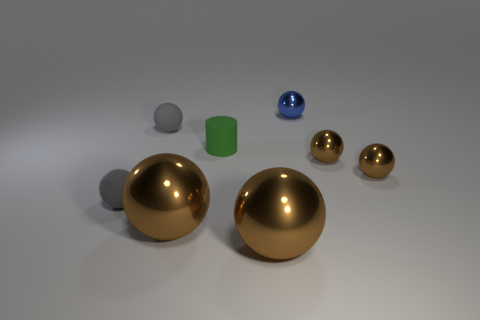How many brown spheres must be subtracted to get 1 brown spheres? 3 Subtract all red blocks. How many brown spheres are left? 4 Subtract 4 balls. How many balls are left? 3 Subtract all gray balls. How many balls are left? 5 Subtract all blue metallic spheres. How many spheres are left? 6 Subtract all green balls. Subtract all red cylinders. How many balls are left? 7 Add 2 small gray matte spheres. How many objects exist? 10 Subtract all spheres. How many objects are left? 1 Add 8 cylinders. How many cylinders exist? 9 Subtract 0 red cubes. How many objects are left? 8 